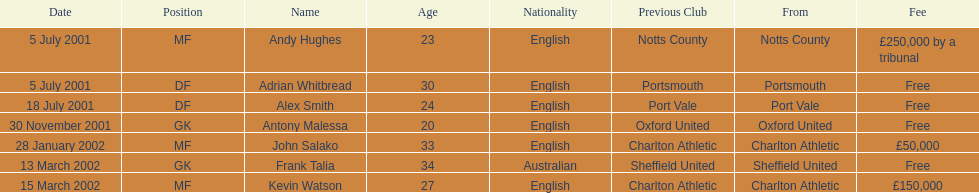Andy huges and adrian whitbread both tranfered on which date? 5 July 2001. 